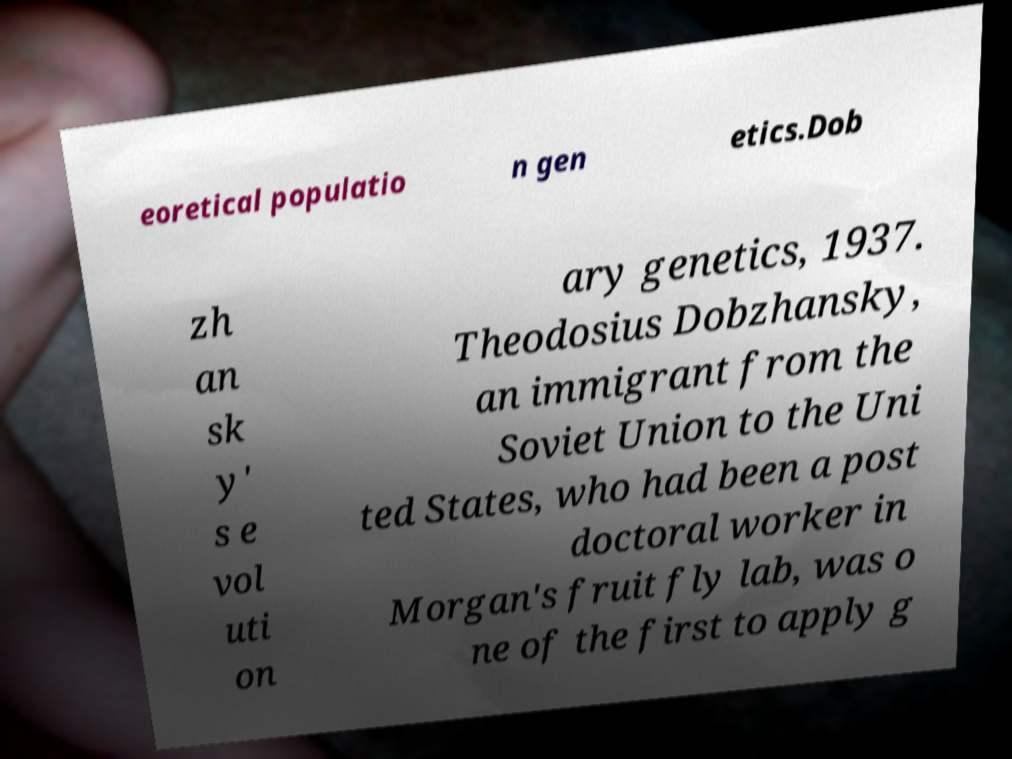Can you accurately transcribe the text from the provided image for me? eoretical populatio n gen etics.Dob zh an sk y' s e vol uti on ary genetics, 1937. Theodosius Dobzhansky, an immigrant from the Soviet Union to the Uni ted States, who had been a post doctoral worker in Morgan's fruit fly lab, was o ne of the first to apply g 